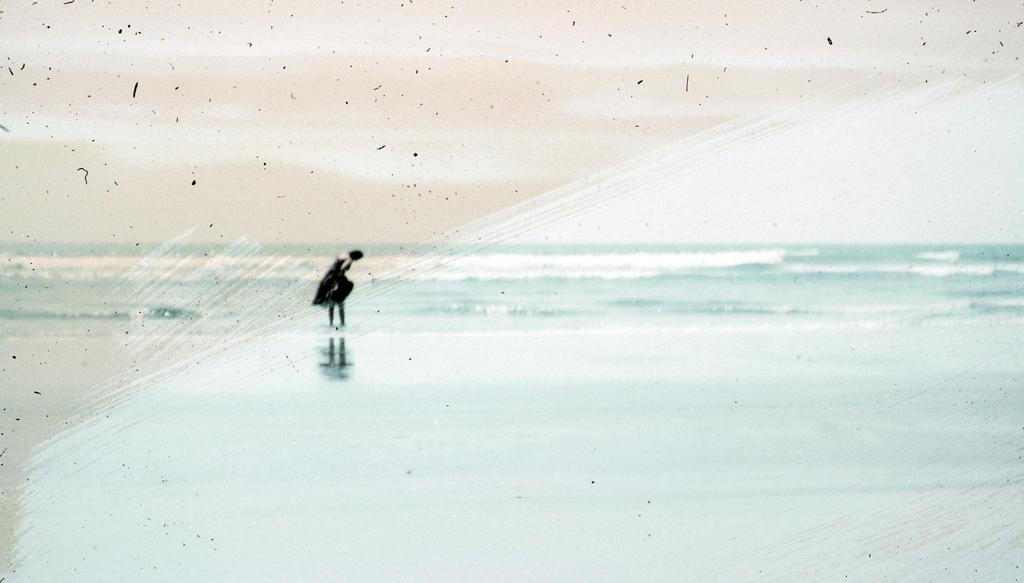Who is the main subject in the image? There is a girl in the image. Where is the girl standing in relation to the river? The girl is standing in front of the river. What type of natural feature is present in the image? There is a river in the image. What can be seen in the background of the image? The sky is visible in the background of the image. What type of milk is the girl holding in the image? There is no milk present in the image; the girl is standing in front of a river. 